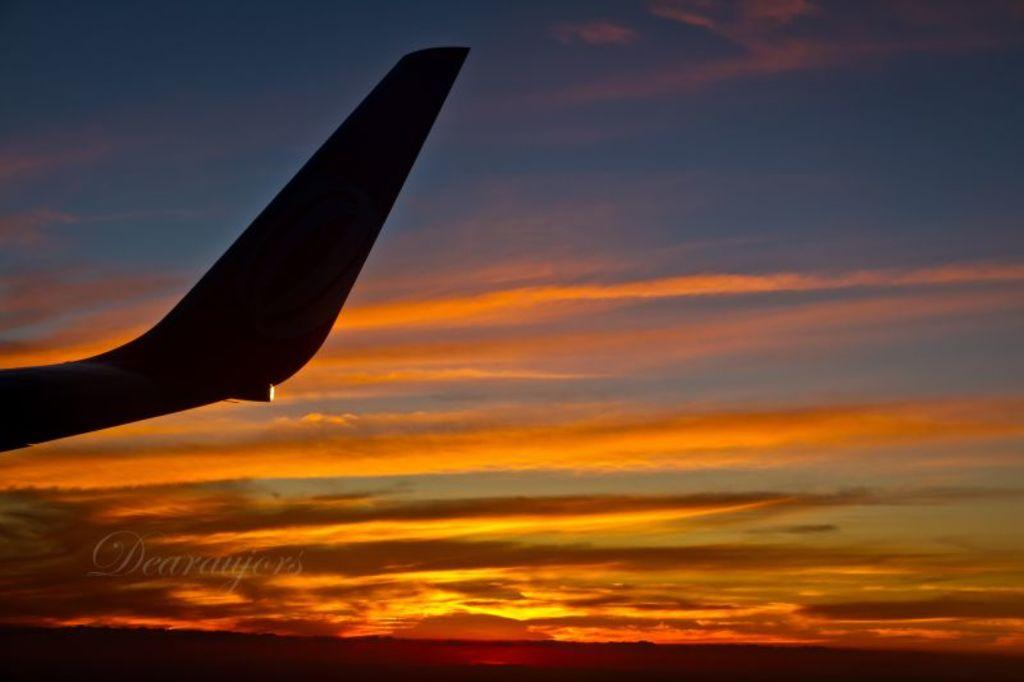<image>
Share a concise interpretation of the image provided. a sunset and airplane wing with words Dearaujers over it 